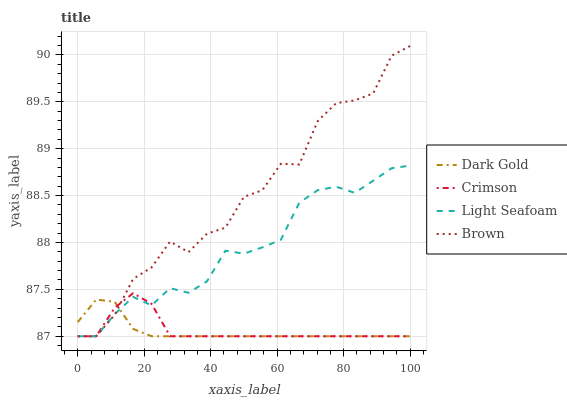Does Dark Gold have the minimum area under the curve?
Answer yes or no. Yes. Does Brown have the maximum area under the curve?
Answer yes or no. Yes. Does Light Seafoam have the minimum area under the curve?
Answer yes or no. No. Does Light Seafoam have the maximum area under the curve?
Answer yes or no. No. Is Dark Gold the smoothest?
Answer yes or no. Yes. Is Brown the roughest?
Answer yes or no. Yes. Is Light Seafoam the smoothest?
Answer yes or no. No. Is Light Seafoam the roughest?
Answer yes or no. No. Does Brown have the highest value?
Answer yes or no. Yes. Does Light Seafoam have the highest value?
Answer yes or no. No. 